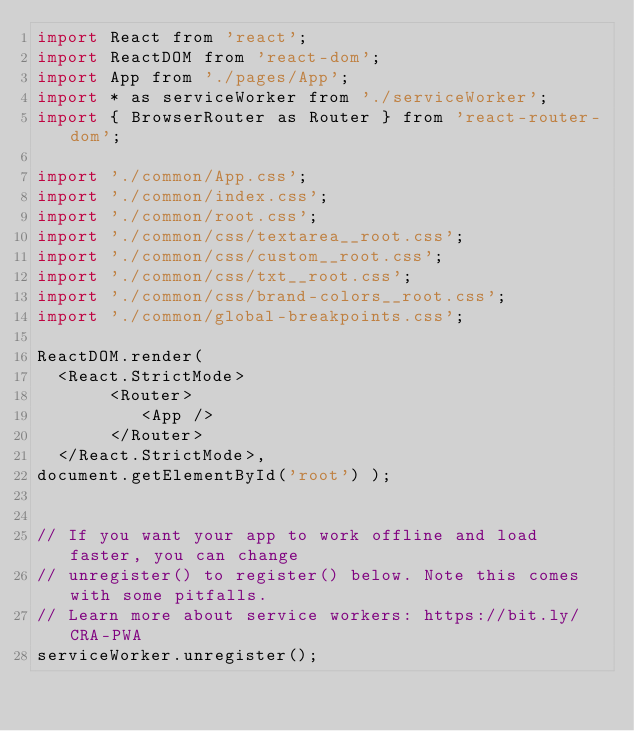<code> <loc_0><loc_0><loc_500><loc_500><_JavaScript_>import React from 'react';
import ReactDOM from 'react-dom';
import App from './pages/App';
import * as serviceWorker from './serviceWorker';
import { BrowserRouter as Router } from 'react-router-dom';

import './common/App.css';
import './common/index.css';
import './common/root.css';
import './common/css/textarea__root.css';
import './common/css/custom__root.css';
import './common/css/txt__root.css';
import './common/css/brand-colors__root.css';
import './common/global-breakpoints.css';

ReactDOM.render(
  <React.StrictMode>
       <Router>
          <App />
       </Router>
  </React.StrictMode>,
document.getElementById('root') );


// If you want your app to work offline and load faster, you can change
// unregister() to register() below. Note this comes with some pitfalls.
// Learn more about service workers: https://bit.ly/CRA-PWA
serviceWorker.unregister();
</code> 